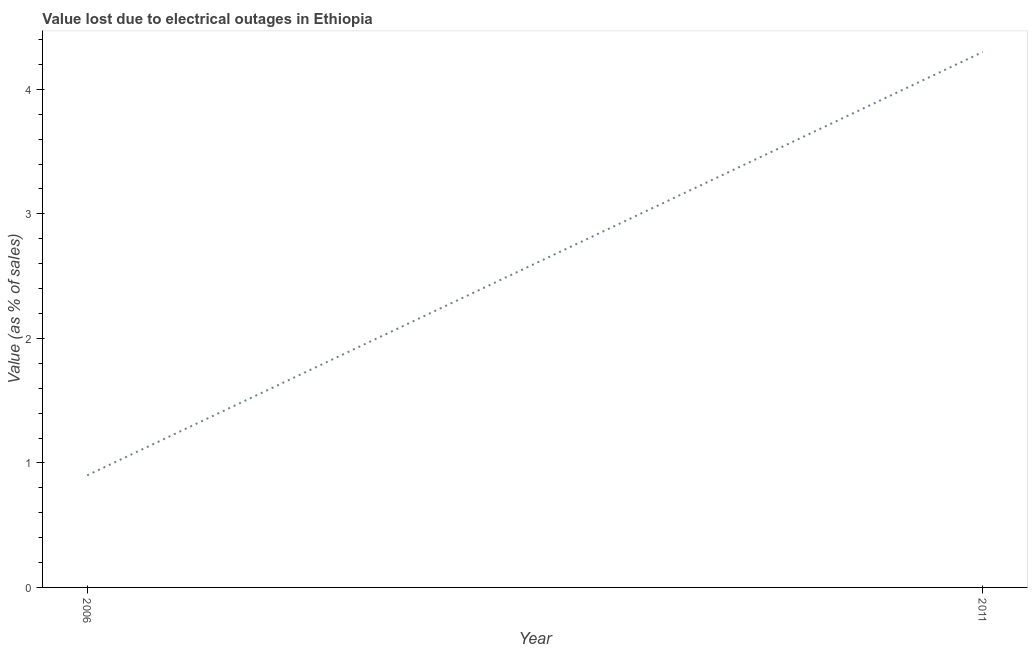What is the value lost due to electrical outages in 2006?
Offer a terse response. 0.9. Across all years, what is the minimum value lost due to electrical outages?
Your response must be concise. 0.9. In which year was the value lost due to electrical outages minimum?
Give a very brief answer. 2006. What is the sum of the value lost due to electrical outages?
Your answer should be compact. 5.2. What is the difference between the value lost due to electrical outages in 2006 and 2011?
Give a very brief answer. -3.4. In how many years, is the value lost due to electrical outages greater than 2.8 %?
Ensure brevity in your answer.  1. What is the ratio of the value lost due to electrical outages in 2006 to that in 2011?
Your answer should be compact. 0.21. Is the value lost due to electrical outages in 2006 less than that in 2011?
Ensure brevity in your answer.  Yes. Does the value lost due to electrical outages monotonically increase over the years?
Give a very brief answer. Yes. How many lines are there?
Ensure brevity in your answer.  1. How many years are there in the graph?
Your response must be concise. 2. What is the title of the graph?
Make the answer very short. Value lost due to electrical outages in Ethiopia. What is the label or title of the Y-axis?
Ensure brevity in your answer.  Value (as % of sales). What is the Value (as % of sales) in 2011?
Your response must be concise. 4.3. What is the ratio of the Value (as % of sales) in 2006 to that in 2011?
Offer a terse response. 0.21. 